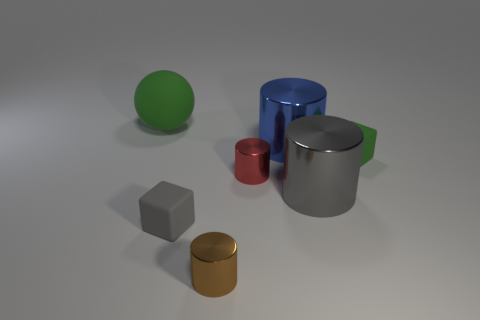There is a large blue metal cylinder; are there any red things to the right of it? Yes, to the right of the large blue cylinder, there is a smaller red cylinder. 